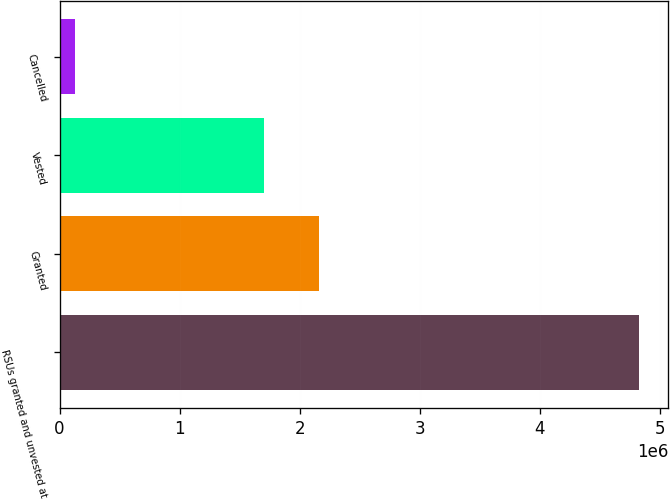Convert chart. <chart><loc_0><loc_0><loc_500><loc_500><bar_chart><fcel>RSUs granted and unvested at<fcel>Granted<fcel>Vested<fcel>Cancelled<nl><fcel>4.82844e+06<fcel>2.16209e+06<fcel>1.70462e+06<fcel>126450<nl></chart> 